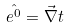<formula> <loc_0><loc_0><loc_500><loc_500>\hat { e ^ { 0 } } = \vec { \nabla } t</formula> 